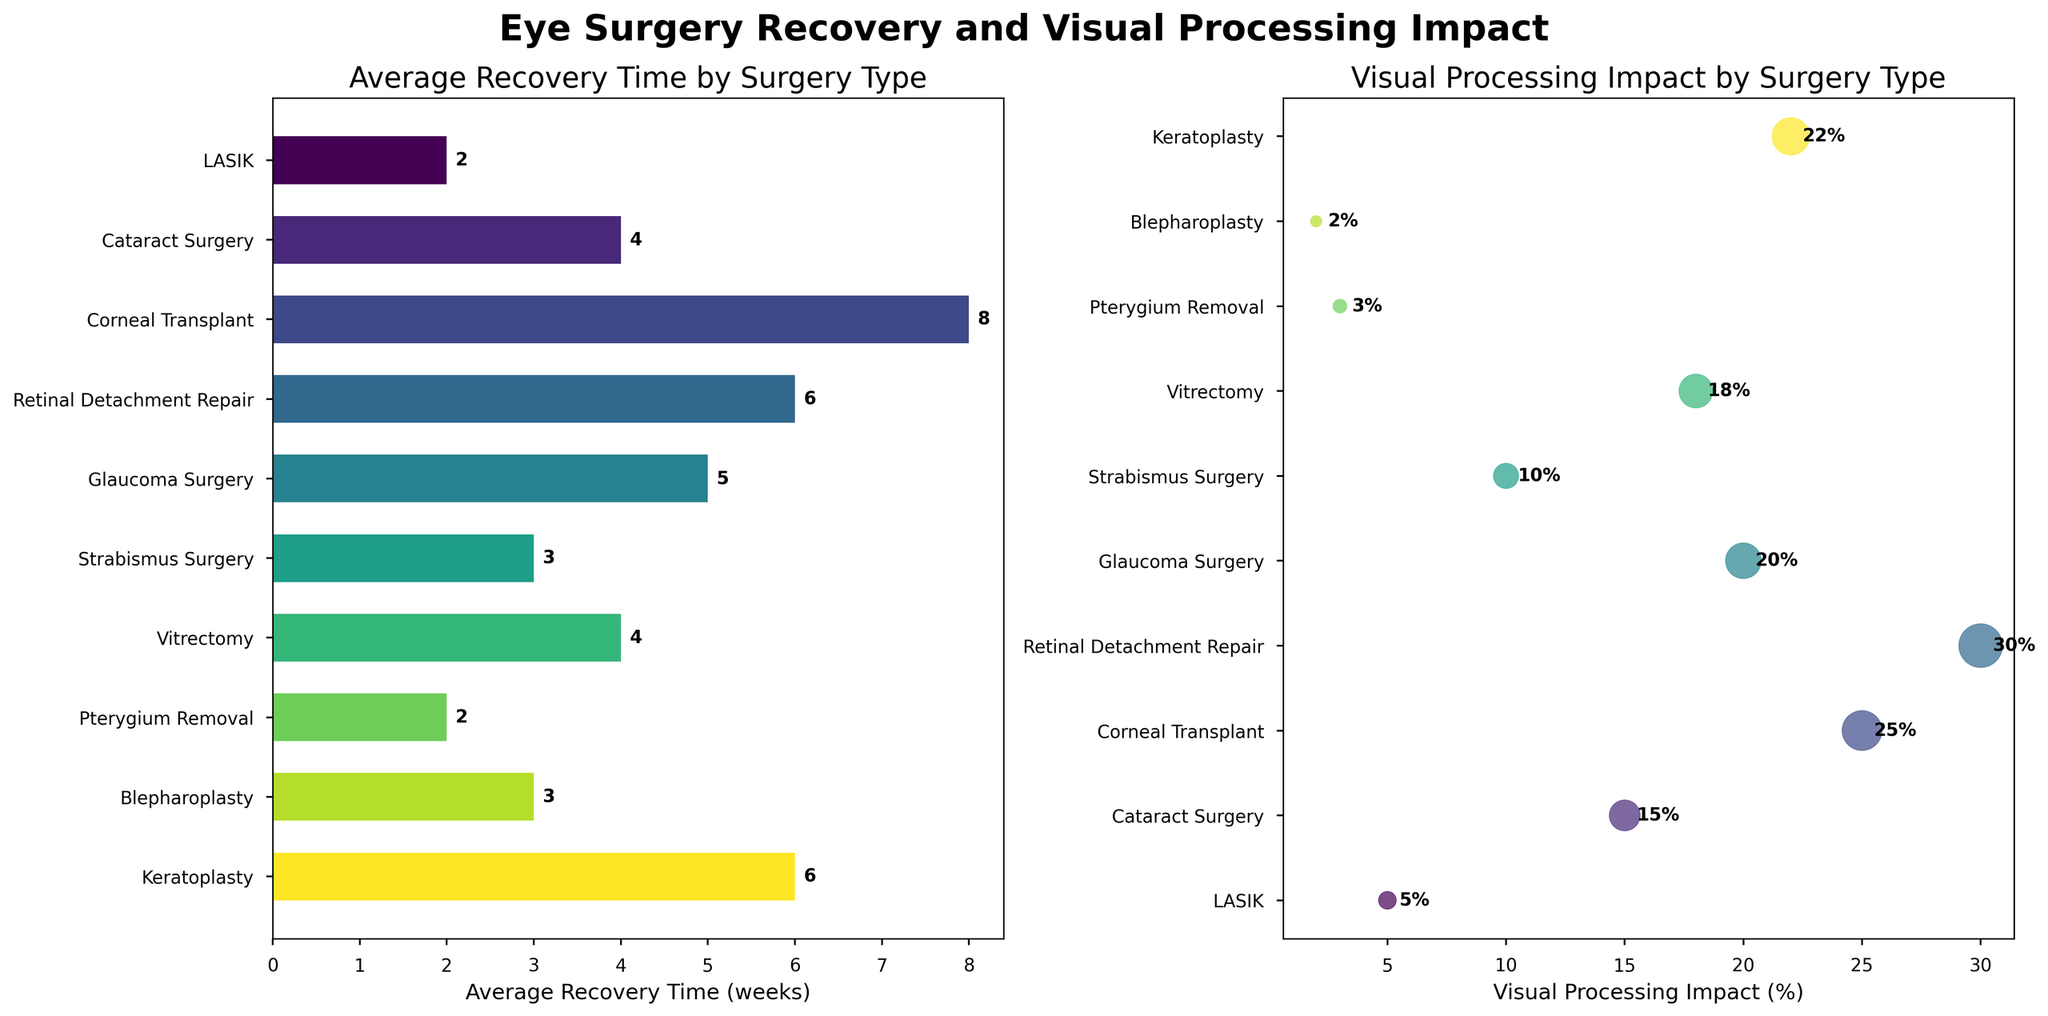What is the average recovery time for LASIK surgery? The horizontal bar for LASIK surgery shows an average recovery time of 2 weeks.
Answer: 2 weeks Which surgery has the highest impact on visual processing? The scatter plot shows that Retinal Detachment Repair has the highest visual processing impact percentage, marked by a significantly larger circle on the rightmost end.
Answer: Retinal Detachment Repair What is the difference in recovery time between Corneal Transplant and LASIK surgery? Corneal Transplant has a recovery time of 8 weeks while LASIK has 2 weeks. The difference is 8 - 2 = 6 weeks.
Answer: 6 weeks How many surgeries have an average recovery time of less than 4 weeks? By checking the horizontal bar graph for surgeries with less than 4 weeks recovery, we count LASIK, Strabismus Surgery, Pterygium Removal, and Blepharoplasty. This makes 4 surgeries.
Answer: 4 surgeries Which surgery type takes longer, Vitrectomy or Cataract Surgery? The horizontal bars show that both Vitrectomy and Cataract Surgery have an average recovery time of 4 weeks. Therefore, neither takes longer.
Answer: Neither What is the correlation between average recovery time and visual processing impact for Retinal Detachment Repair? Retinal Detachment Repair has an average recovery time of 6 weeks and a visual processing impact of 30%. Both values are relatively high compared to other surgeries, indicating a positive correlation.
Answer: Positive correlation How does the recovery time for Glaucoma Surgery compare with that of Keratoplasty? The horizontal bars show that Glaucoma Surgery has an average recovery time of 5 weeks, whereas Keratoplasty has 6 weeks, making Keratoplasty longer.
Answer: Keratoplasty is longer Which surgeries have the least visual processing impact and what are their recovery times? The scatter plot shows that Blepharoplasty and Pterygium Removal have the least visual processing impacts of 2% and 3% respectively. Their recovery times from the horizontal bar graph are 3 weeks and 2 weeks.
Answer: Blepharoplasty (3 weeks), Pterygium Removal (2 weeks) What is the average visual processing impact for surgeries with recovery times greater than 4 weeks? Surgeries with recovery times > 4 weeks are Corneal Transplant (25%), Retinal Detachment Repair (30%), Glaucoma Surgery (20%), and Keratoplasty (22%). The average impact is \(\frac{25 + 30 + 20 + 22}{4} = 24.25%\).
Answer: 24.25% Which surgery type with an average recovery time of 3 weeks has a higher visual processing impact? Both Strabismus Surgery and Blepharoplasty have 3 weeks recovery time. Strabismus Surgery has a 10% impact, whereas Blepharoplasty has a 2% impact. So, Strabismus Surgery has the higher impact.
Answer: Strabismus Surgery 